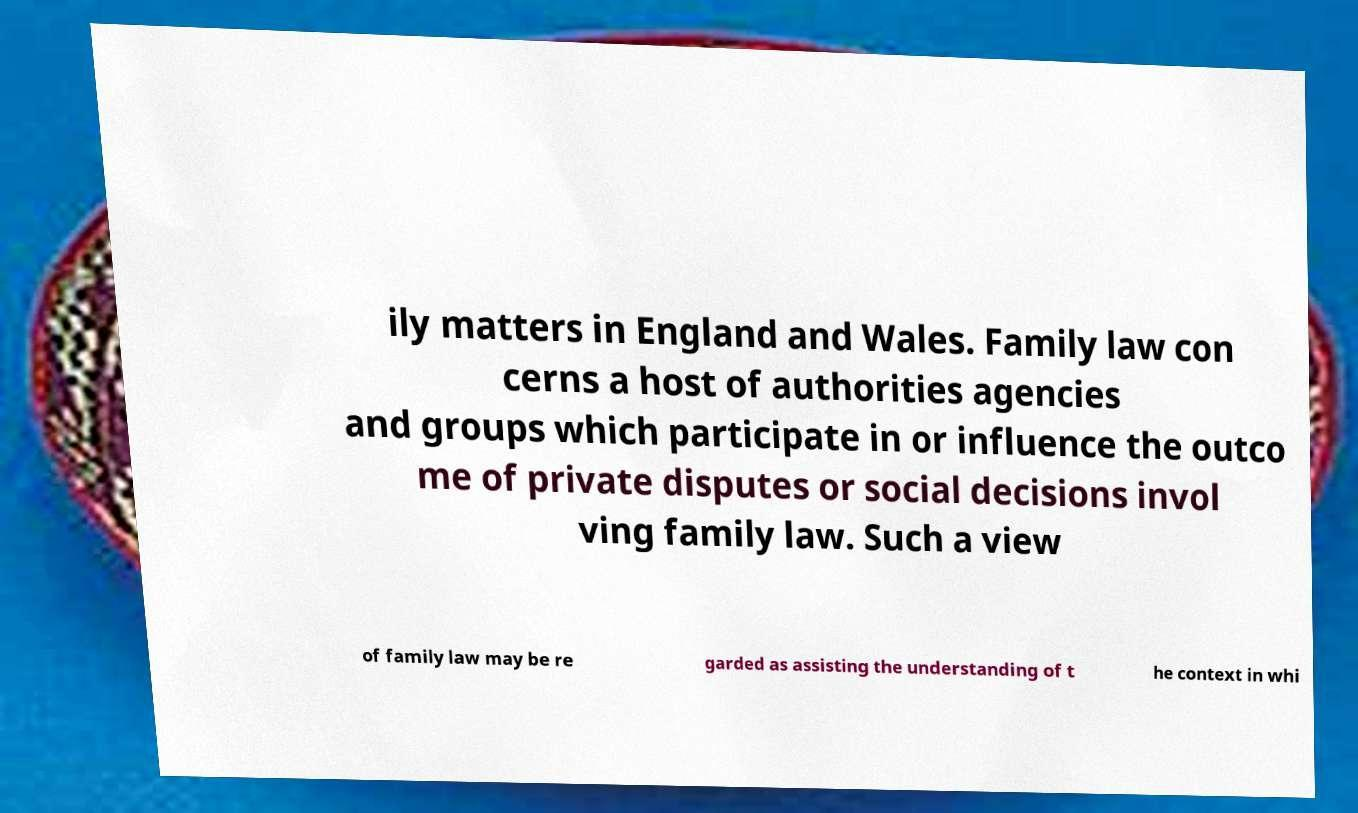Could you assist in decoding the text presented in this image and type it out clearly? ily matters in England and Wales. Family law con cerns a host of authorities agencies and groups which participate in or influence the outco me of private disputes or social decisions invol ving family law. Such a view of family law may be re garded as assisting the understanding of t he context in whi 